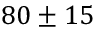<formula> <loc_0><loc_0><loc_500><loc_500>8 0 \pm 1 5</formula> 